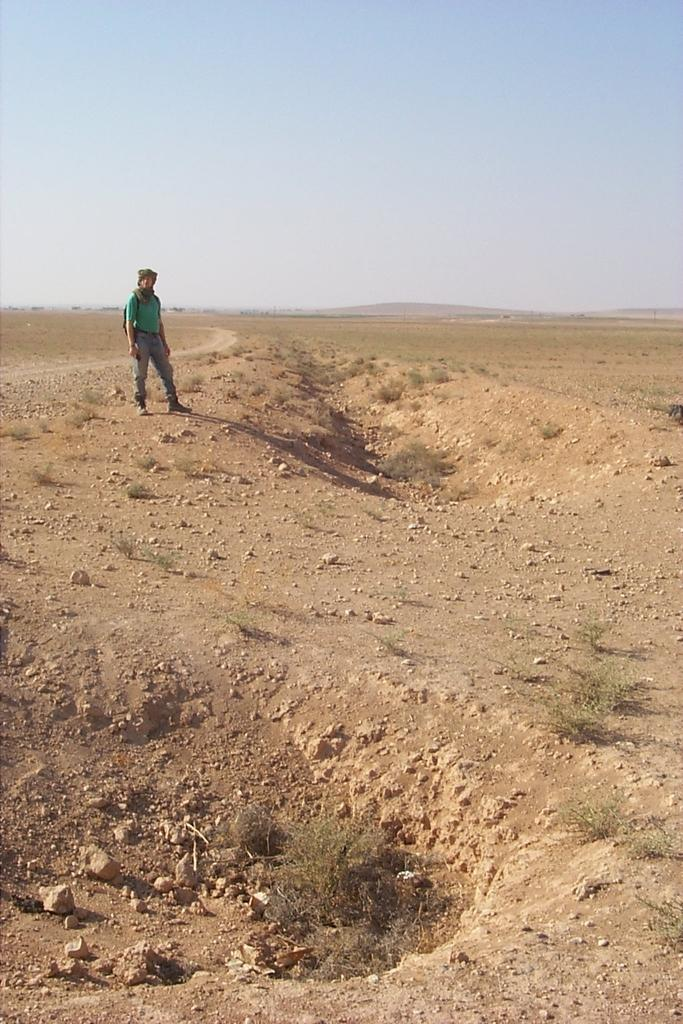What can be seen in the background of the image? The sky is visible in the background of the image. Who is present in the image? There is a man in the image. What is the man wearing? The man is wearing a t-shirt. What is the man's posture in the image? The man is standing. What type of surface is under the man's feet in the image? There are stones on the ground in the image. How much does the dime cost in the image? There is no dime present in the image, so it is not possible to determine its cost. 